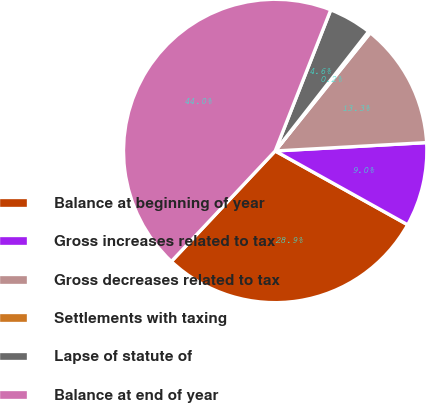Convert chart. <chart><loc_0><loc_0><loc_500><loc_500><pie_chart><fcel>Balance at beginning of year<fcel>Gross increases related to tax<fcel>Gross decreases related to tax<fcel>Settlements with taxing<fcel>Lapse of statute of<fcel>Balance at end of year<nl><fcel>28.92%<fcel>8.97%<fcel>13.34%<fcel>0.22%<fcel>4.59%<fcel>43.97%<nl></chart> 